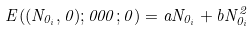Convert formula to latex. <formula><loc_0><loc_0><loc_500><loc_500>E ( ( N _ { 0 _ { i } } , 0 ) ; 0 0 0 ; 0 ) = a N _ { 0 _ { i } } + b N _ { 0 _ { i } } ^ { 2 }</formula> 